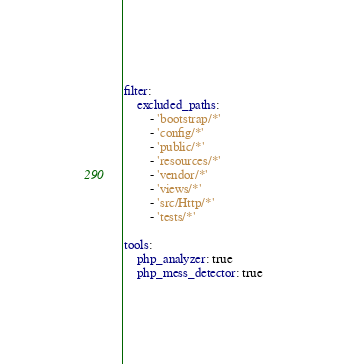Convert code to text. <code><loc_0><loc_0><loc_500><loc_500><_YAML_>filter:
    excluded_paths:
        - 'bootstrap/*'
        - 'config/*'
        - 'public/*'
        - 'resources/*'
        - 'vendor/*'
        - 'views/*'
        - 'src/Http/*'
        - 'tests/*'

tools:
    php_analyzer: true
    php_mess_detector: true</code> 